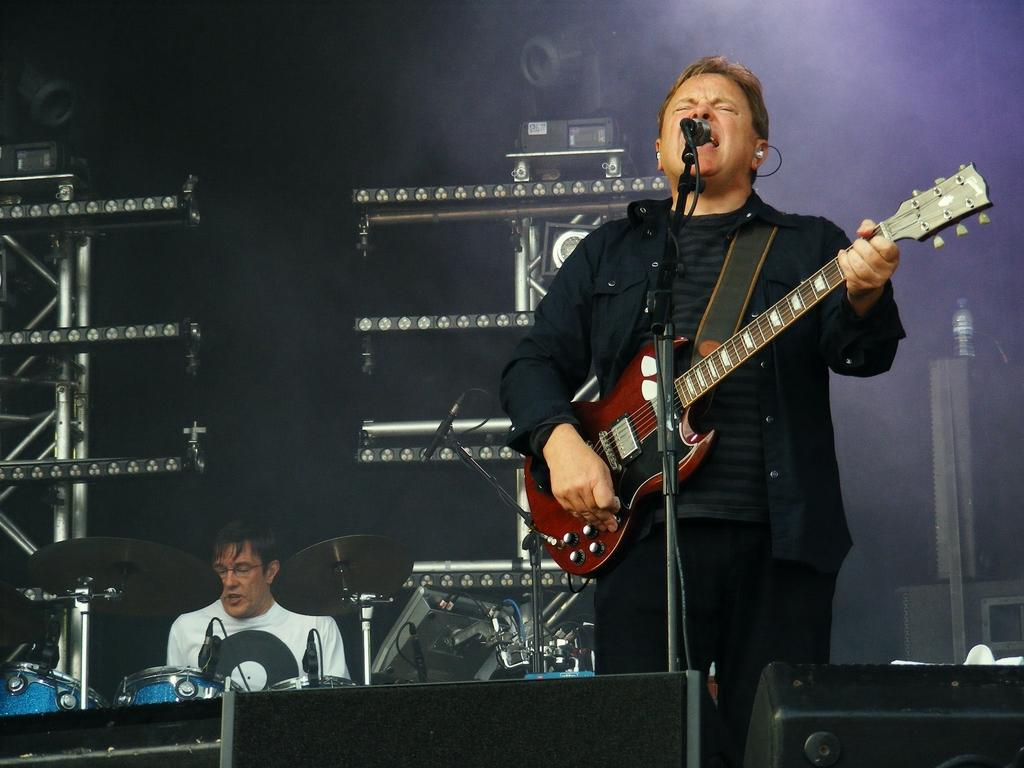How many people are in the image? There are two men in the image. What is one of the men holding in the image? One man is holding a guitar in the image. Where is the man with the guitar positioned in relation to the microphone? The man with the guitar is in front of a microphone. What can be seen near the other man in the image? The other man is near drums in the image. What type of equipment is visible in the background of the image? There are equipment visible in the background of the image. What type of wave is being created by the theory in the image? There is no wave or theory present in the image; it features two men, one with a guitar and the other near drums. 